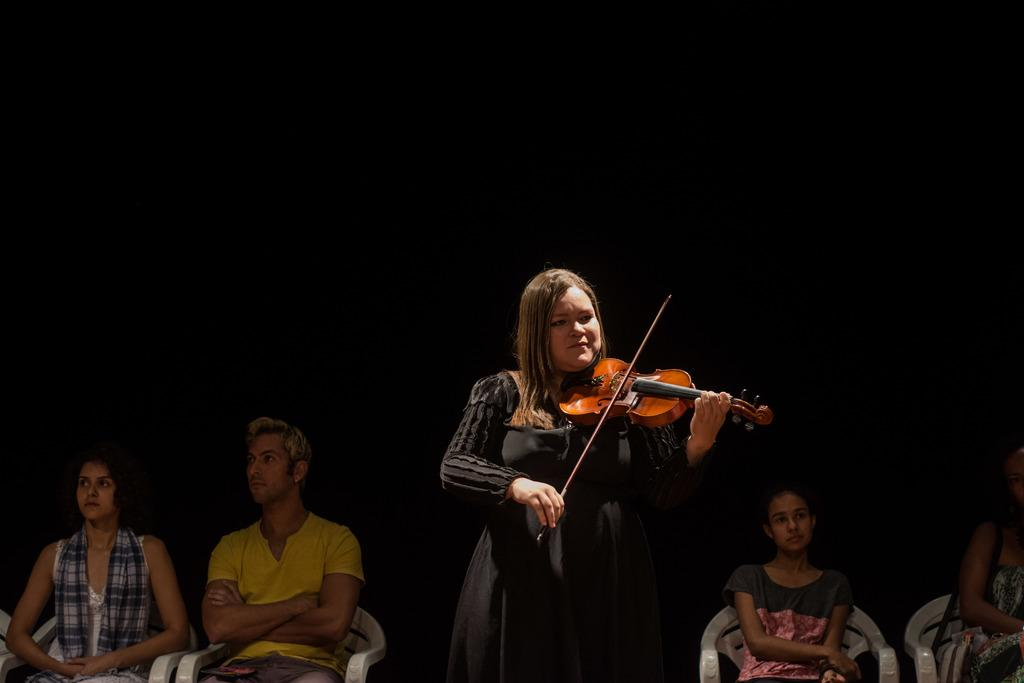Who is the main subject in the image? There is a woman in the image. Where is the woman positioned in the image? The woman is standing in the center of the image. What is the woman doing in the image? The woman is playing a guitar. Can you describe the other people in the image? There are two persons sitting on a chair and two persons on the right side of the image. What type of oatmeal is being served on the left side of the image? There is no oatmeal present in the image. What decision is the woman making in the image? The image does not depict the woman making a decision; she is playing a guitar. 